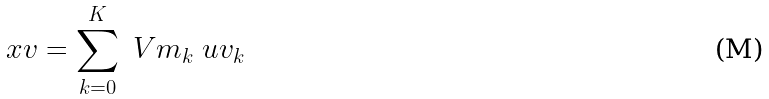Convert formula to latex. <formula><loc_0><loc_0><loc_500><loc_500>\ x v = \sum _ { k = 0 } ^ { K } \ V m _ { k } \ u v _ { k }</formula> 